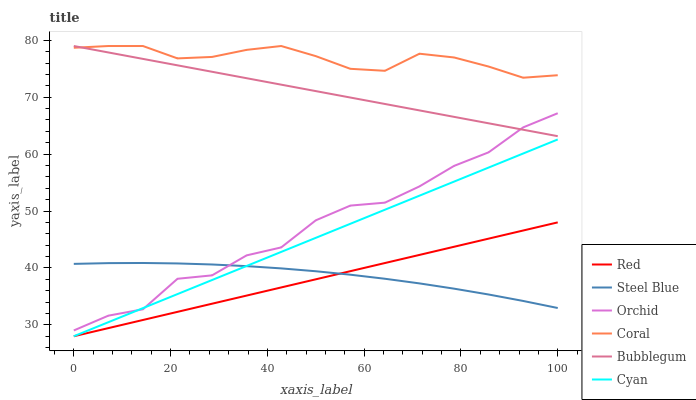Does Red have the minimum area under the curve?
Answer yes or no. Yes. Does Coral have the maximum area under the curve?
Answer yes or no. Yes. Does Steel Blue have the minimum area under the curve?
Answer yes or no. No. Does Steel Blue have the maximum area under the curve?
Answer yes or no. No. Is Red the smoothest?
Answer yes or no. Yes. Is Orchid the roughest?
Answer yes or no. Yes. Is Steel Blue the smoothest?
Answer yes or no. No. Is Steel Blue the roughest?
Answer yes or no. No. Does Cyan have the lowest value?
Answer yes or no. Yes. Does Steel Blue have the lowest value?
Answer yes or no. No. Does Bubblegum have the highest value?
Answer yes or no. Yes. Does Steel Blue have the highest value?
Answer yes or no. No. Is Red less than Coral?
Answer yes or no. Yes. Is Bubblegum greater than Cyan?
Answer yes or no. Yes. Does Cyan intersect Orchid?
Answer yes or no. Yes. Is Cyan less than Orchid?
Answer yes or no. No. Is Cyan greater than Orchid?
Answer yes or no. No. Does Red intersect Coral?
Answer yes or no. No. 